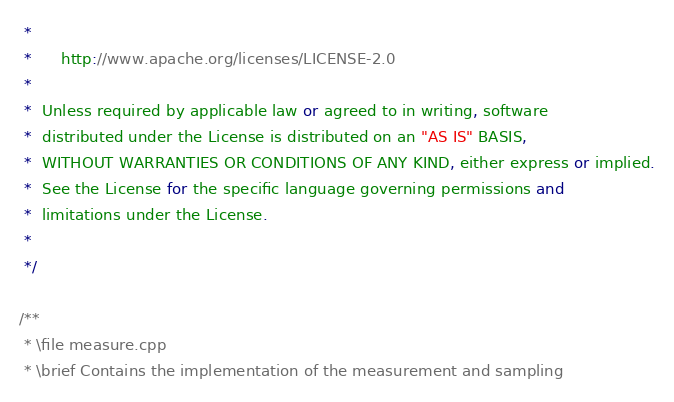Convert code to text. <code><loc_0><loc_0><loc_500><loc_500><_C++_> *
 *      http://www.apache.org/licenses/LICENSE-2.0
 *
 *  Unless required by applicable law or agreed to in writing, software
 *  distributed under the License is distributed on an "AS IS" BASIS,
 *  WITHOUT WARRANTIES OR CONDITIONS OF ANY KIND, either express or implied.
 *  See the License for the specific language governing permissions and
 *  limitations under the License.
 *
 */
 
/**
 * \file measure.cpp
 * \brief Contains the implementation of the measurement and sampling </code> 